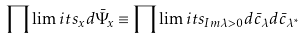<formula> <loc_0><loc_0><loc_500><loc_500>\prod \lim i t s _ { x } d \bar { \Psi } _ { x } \equiv \prod \lim i t s _ { I m \lambda > 0 } d \bar { c } _ { \lambda } d \bar { c } _ { \lambda ^ { * } }</formula> 